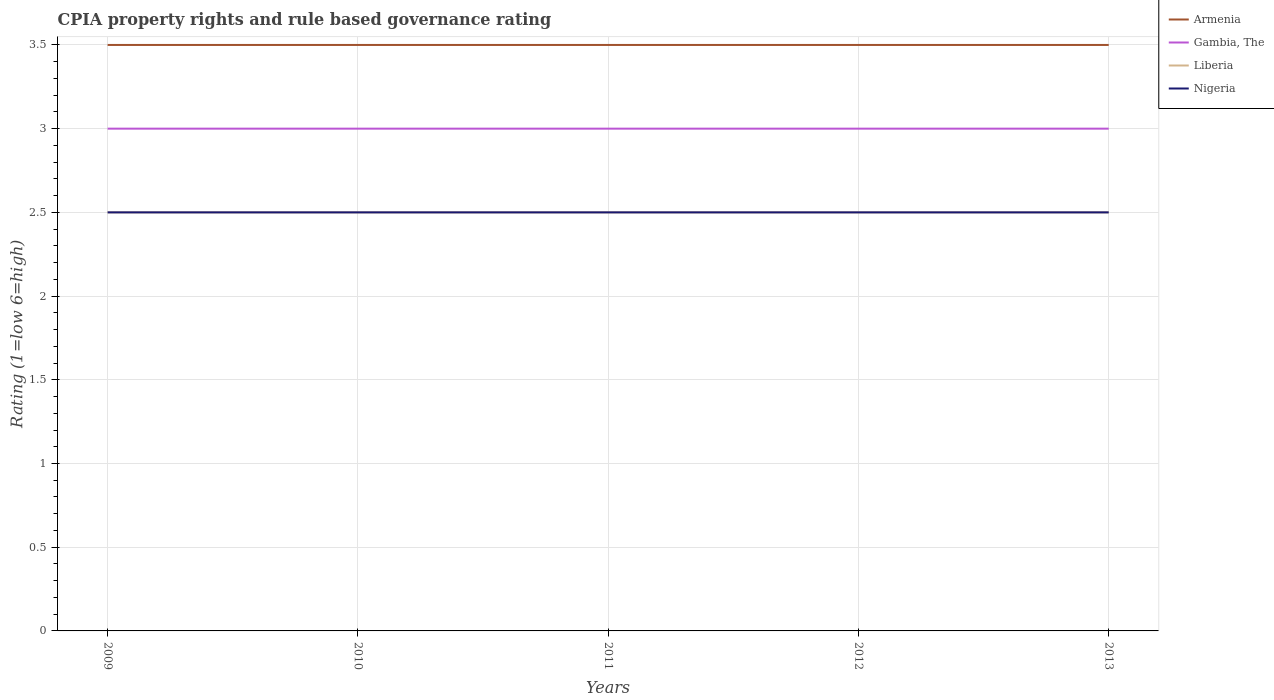Does the line corresponding to Armenia intersect with the line corresponding to Nigeria?
Provide a succinct answer. No. Across all years, what is the maximum CPIA rating in Armenia?
Your response must be concise. 3.5. What is the total CPIA rating in Liberia in the graph?
Your answer should be very brief. 0. What is the difference between the highest and the second highest CPIA rating in Armenia?
Keep it short and to the point. 0. What is the difference between the highest and the lowest CPIA rating in Armenia?
Provide a succinct answer. 0. How many lines are there?
Your answer should be compact. 4. How many years are there in the graph?
Your answer should be very brief. 5. Does the graph contain any zero values?
Ensure brevity in your answer.  No. How are the legend labels stacked?
Your answer should be compact. Vertical. What is the title of the graph?
Keep it short and to the point. CPIA property rights and rule based governance rating. Does "Micronesia" appear as one of the legend labels in the graph?
Your answer should be compact. No. What is the label or title of the X-axis?
Offer a very short reply. Years. What is the label or title of the Y-axis?
Keep it short and to the point. Rating (1=low 6=high). What is the Rating (1=low 6=high) of Liberia in 2009?
Offer a terse response. 2.5. What is the Rating (1=low 6=high) of Gambia, The in 2010?
Your response must be concise. 3. What is the Rating (1=low 6=high) in Nigeria in 2010?
Provide a succinct answer. 2.5. What is the Rating (1=low 6=high) of Gambia, The in 2011?
Give a very brief answer. 3. What is the Rating (1=low 6=high) in Liberia in 2011?
Your answer should be compact. 2.5. What is the Rating (1=low 6=high) of Nigeria in 2012?
Give a very brief answer. 2.5. What is the Rating (1=low 6=high) of Armenia in 2013?
Provide a succinct answer. 3.5. What is the Rating (1=low 6=high) of Nigeria in 2013?
Give a very brief answer. 2.5. Across all years, what is the maximum Rating (1=low 6=high) in Liberia?
Your response must be concise. 2.5. Across all years, what is the minimum Rating (1=low 6=high) in Armenia?
Offer a very short reply. 3.5. Across all years, what is the minimum Rating (1=low 6=high) of Gambia, The?
Your answer should be compact. 3. Across all years, what is the minimum Rating (1=low 6=high) of Nigeria?
Your answer should be very brief. 2.5. What is the total Rating (1=low 6=high) of Armenia in the graph?
Your response must be concise. 17.5. What is the total Rating (1=low 6=high) of Gambia, The in the graph?
Give a very brief answer. 15. What is the difference between the Rating (1=low 6=high) of Armenia in 2009 and that in 2010?
Make the answer very short. 0. What is the difference between the Rating (1=low 6=high) in Gambia, The in 2009 and that in 2010?
Your response must be concise. 0. What is the difference between the Rating (1=low 6=high) of Nigeria in 2009 and that in 2010?
Your response must be concise. 0. What is the difference between the Rating (1=low 6=high) of Armenia in 2009 and that in 2011?
Make the answer very short. 0. What is the difference between the Rating (1=low 6=high) of Gambia, The in 2009 and that in 2011?
Provide a succinct answer. 0. What is the difference between the Rating (1=low 6=high) in Gambia, The in 2009 and that in 2012?
Offer a very short reply. 0. What is the difference between the Rating (1=low 6=high) in Liberia in 2009 and that in 2012?
Give a very brief answer. 0. What is the difference between the Rating (1=low 6=high) of Armenia in 2010 and that in 2011?
Make the answer very short. 0. What is the difference between the Rating (1=low 6=high) of Gambia, The in 2010 and that in 2011?
Provide a short and direct response. 0. What is the difference between the Rating (1=low 6=high) in Nigeria in 2010 and that in 2011?
Your response must be concise. 0. What is the difference between the Rating (1=low 6=high) in Gambia, The in 2010 and that in 2012?
Offer a very short reply. 0. What is the difference between the Rating (1=low 6=high) of Liberia in 2010 and that in 2012?
Keep it short and to the point. 0. What is the difference between the Rating (1=low 6=high) of Nigeria in 2010 and that in 2012?
Your answer should be very brief. 0. What is the difference between the Rating (1=low 6=high) of Armenia in 2010 and that in 2013?
Your response must be concise. 0. What is the difference between the Rating (1=low 6=high) in Gambia, The in 2010 and that in 2013?
Your answer should be compact. 0. What is the difference between the Rating (1=low 6=high) in Liberia in 2010 and that in 2013?
Give a very brief answer. 0. What is the difference between the Rating (1=low 6=high) of Nigeria in 2010 and that in 2013?
Make the answer very short. 0. What is the difference between the Rating (1=low 6=high) in Armenia in 2011 and that in 2012?
Your answer should be compact. 0. What is the difference between the Rating (1=low 6=high) of Gambia, The in 2011 and that in 2012?
Your answer should be compact. 0. What is the difference between the Rating (1=low 6=high) of Nigeria in 2011 and that in 2012?
Ensure brevity in your answer.  0. What is the difference between the Rating (1=low 6=high) of Armenia in 2011 and that in 2013?
Offer a terse response. 0. What is the difference between the Rating (1=low 6=high) of Liberia in 2011 and that in 2013?
Your answer should be very brief. 0. What is the difference between the Rating (1=low 6=high) of Nigeria in 2011 and that in 2013?
Make the answer very short. 0. What is the difference between the Rating (1=low 6=high) in Armenia in 2012 and that in 2013?
Your answer should be compact. 0. What is the difference between the Rating (1=low 6=high) of Gambia, The in 2012 and that in 2013?
Give a very brief answer. 0. What is the difference between the Rating (1=low 6=high) of Armenia in 2009 and the Rating (1=low 6=high) of Gambia, The in 2010?
Keep it short and to the point. 0.5. What is the difference between the Rating (1=low 6=high) in Armenia in 2009 and the Rating (1=low 6=high) in Liberia in 2010?
Offer a very short reply. 1. What is the difference between the Rating (1=low 6=high) of Armenia in 2009 and the Rating (1=low 6=high) of Nigeria in 2010?
Your response must be concise. 1. What is the difference between the Rating (1=low 6=high) of Gambia, The in 2009 and the Rating (1=low 6=high) of Nigeria in 2010?
Your answer should be very brief. 0.5. What is the difference between the Rating (1=low 6=high) in Liberia in 2009 and the Rating (1=low 6=high) in Nigeria in 2010?
Your answer should be very brief. 0. What is the difference between the Rating (1=low 6=high) in Armenia in 2009 and the Rating (1=low 6=high) in Gambia, The in 2011?
Your response must be concise. 0.5. What is the difference between the Rating (1=low 6=high) in Armenia in 2009 and the Rating (1=low 6=high) in Liberia in 2011?
Provide a short and direct response. 1. What is the difference between the Rating (1=low 6=high) in Armenia in 2009 and the Rating (1=low 6=high) in Nigeria in 2011?
Keep it short and to the point. 1. What is the difference between the Rating (1=low 6=high) in Liberia in 2009 and the Rating (1=low 6=high) in Nigeria in 2011?
Keep it short and to the point. 0. What is the difference between the Rating (1=low 6=high) in Armenia in 2009 and the Rating (1=low 6=high) in Liberia in 2012?
Your answer should be compact. 1. What is the difference between the Rating (1=low 6=high) of Gambia, The in 2009 and the Rating (1=low 6=high) of Liberia in 2013?
Your answer should be compact. 0.5. What is the difference between the Rating (1=low 6=high) in Armenia in 2010 and the Rating (1=low 6=high) in Gambia, The in 2012?
Keep it short and to the point. 0.5. What is the difference between the Rating (1=low 6=high) in Armenia in 2010 and the Rating (1=low 6=high) in Liberia in 2012?
Ensure brevity in your answer.  1. What is the difference between the Rating (1=low 6=high) in Gambia, The in 2010 and the Rating (1=low 6=high) in Nigeria in 2012?
Give a very brief answer. 0.5. What is the difference between the Rating (1=low 6=high) of Liberia in 2010 and the Rating (1=low 6=high) of Nigeria in 2012?
Provide a short and direct response. 0. What is the difference between the Rating (1=low 6=high) of Armenia in 2011 and the Rating (1=low 6=high) of Gambia, The in 2012?
Ensure brevity in your answer.  0.5. What is the difference between the Rating (1=low 6=high) of Armenia in 2011 and the Rating (1=low 6=high) of Nigeria in 2012?
Your answer should be very brief. 1. What is the difference between the Rating (1=low 6=high) of Liberia in 2011 and the Rating (1=low 6=high) of Nigeria in 2012?
Provide a short and direct response. 0. What is the difference between the Rating (1=low 6=high) of Armenia in 2011 and the Rating (1=low 6=high) of Gambia, The in 2013?
Give a very brief answer. 0.5. What is the difference between the Rating (1=low 6=high) of Armenia in 2011 and the Rating (1=low 6=high) of Liberia in 2013?
Ensure brevity in your answer.  1. What is the difference between the Rating (1=low 6=high) in Gambia, The in 2011 and the Rating (1=low 6=high) in Liberia in 2013?
Ensure brevity in your answer.  0.5. What is the difference between the Rating (1=low 6=high) in Gambia, The in 2011 and the Rating (1=low 6=high) in Nigeria in 2013?
Offer a very short reply. 0.5. What is the difference between the Rating (1=low 6=high) in Liberia in 2011 and the Rating (1=low 6=high) in Nigeria in 2013?
Your answer should be very brief. 0. What is the difference between the Rating (1=low 6=high) in Armenia in 2012 and the Rating (1=low 6=high) in Gambia, The in 2013?
Keep it short and to the point. 0.5. What is the difference between the Rating (1=low 6=high) in Gambia, The in 2012 and the Rating (1=low 6=high) in Liberia in 2013?
Offer a very short reply. 0.5. What is the difference between the Rating (1=low 6=high) in Gambia, The in 2012 and the Rating (1=low 6=high) in Nigeria in 2013?
Keep it short and to the point. 0.5. What is the average Rating (1=low 6=high) of Armenia per year?
Give a very brief answer. 3.5. What is the average Rating (1=low 6=high) in Liberia per year?
Make the answer very short. 2.5. What is the average Rating (1=low 6=high) in Nigeria per year?
Give a very brief answer. 2.5. In the year 2009, what is the difference between the Rating (1=low 6=high) in Armenia and Rating (1=low 6=high) in Gambia, The?
Offer a very short reply. 0.5. In the year 2009, what is the difference between the Rating (1=low 6=high) in Gambia, The and Rating (1=low 6=high) in Liberia?
Offer a terse response. 0.5. In the year 2010, what is the difference between the Rating (1=low 6=high) in Armenia and Rating (1=low 6=high) in Gambia, The?
Provide a succinct answer. 0.5. In the year 2010, what is the difference between the Rating (1=low 6=high) of Gambia, The and Rating (1=low 6=high) of Nigeria?
Your response must be concise. 0.5. In the year 2010, what is the difference between the Rating (1=low 6=high) of Liberia and Rating (1=low 6=high) of Nigeria?
Your response must be concise. 0. In the year 2011, what is the difference between the Rating (1=low 6=high) of Armenia and Rating (1=low 6=high) of Gambia, The?
Provide a succinct answer. 0.5. In the year 2011, what is the difference between the Rating (1=low 6=high) of Gambia, The and Rating (1=low 6=high) of Nigeria?
Ensure brevity in your answer.  0.5. In the year 2012, what is the difference between the Rating (1=low 6=high) of Armenia and Rating (1=low 6=high) of Nigeria?
Your response must be concise. 1. In the year 2012, what is the difference between the Rating (1=low 6=high) in Gambia, The and Rating (1=low 6=high) in Liberia?
Ensure brevity in your answer.  0.5. In the year 2012, what is the difference between the Rating (1=low 6=high) in Gambia, The and Rating (1=low 6=high) in Nigeria?
Give a very brief answer. 0.5. In the year 2012, what is the difference between the Rating (1=low 6=high) of Liberia and Rating (1=low 6=high) of Nigeria?
Provide a short and direct response. 0. In the year 2013, what is the difference between the Rating (1=low 6=high) in Armenia and Rating (1=low 6=high) in Liberia?
Give a very brief answer. 1. In the year 2013, what is the difference between the Rating (1=low 6=high) of Gambia, The and Rating (1=low 6=high) of Liberia?
Ensure brevity in your answer.  0.5. What is the ratio of the Rating (1=low 6=high) of Armenia in 2009 to that in 2010?
Give a very brief answer. 1. What is the ratio of the Rating (1=low 6=high) of Nigeria in 2009 to that in 2010?
Give a very brief answer. 1. What is the ratio of the Rating (1=low 6=high) in Armenia in 2009 to that in 2011?
Offer a very short reply. 1. What is the ratio of the Rating (1=low 6=high) in Gambia, The in 2009 to that in 2011?
Your answer should be very brief. 1. What is the ratio of the Rating (1=low 6=high) of Liberia in 2009 to that in 2011?
Make the answer very short. 1. What is the ratio of the Rating (1=low 6=high) in Nigeria in 2009 to that in 2011?
Ensure brevity in your answer.  1. What is the ratio of the Rating (1=low 6=high) of Armenia in 2009 to that in 2012?
Provide a short and direct response. 1. What is the ratio of the Rating (1=low 6=high) of Gambia, The in 2009 to that in 2012?
Offer a very short reply. 1. What is the ratio of the Rating (1=low 6=high) in Nigeria in 2009 to that in 2012?
Make the answer very short. 1. What is the ratio of the Rating (1=low 6=high) in Armenia in 2009 to that in 2013?
Give a very brief answer. 1. What is the ratio of the Rating (1=low 6=high) in Gambia, The in 2009 to that in 2013?
Provide a succinct answer. 1. What is the ratio of the Rating (1=low 6=high) of Nigeria in 2009 to that in 2013?
Give a very brief answer. 1. What is the ratio of the Rating (1=low 6=high) of Armenia in 2010 to that in 2012?
Offer a very short reply. 1. What is the ratio of the Rating (1=low 6=high) in Liberia in 2010 to that in 2012?
Give a very brief answer. 1. What is the ratio of the Rating (1=low 6=high) in Liberia in 2010 to that in 2013?
Provide a succinct answer. 1. What is the ratio of the Rating (1=low 6=high) of Armenia in 2011 to that in 2012?
Offer a terse response. 1. What is the ratio of the Rating (1=low 6=high) of Gambia, The in 2011 to that in 2012?
Give a very brief answer. 1. What is the ratio of the Rating (1=low 6=high) in Nigeria in 2011 to that in 2012?
Your response must be concise. 1. What is the ratio of the Rating (1=low 6=high) in Gambia, The in 2011 to that in 2013?
Your answer should be very brief. 1. What is the ratio of the Rating (1=low 6=high) of Nigeria in 2011 to that in 2013?
Keep it short and to the point. 1. What is the ratio of the Rating (1=low 6=high) of Nigeria in 2012 to that in 2013?
Your answer should be compact. 1. What is the difference between the highest and the second highest Rating (1=low 6=high) in Armenia?
Provide a succinct answer. 0. What is the difference between the highest and the lowest Rating (1=low 6=high) in Liberia?
Make the answer very short. 0. 